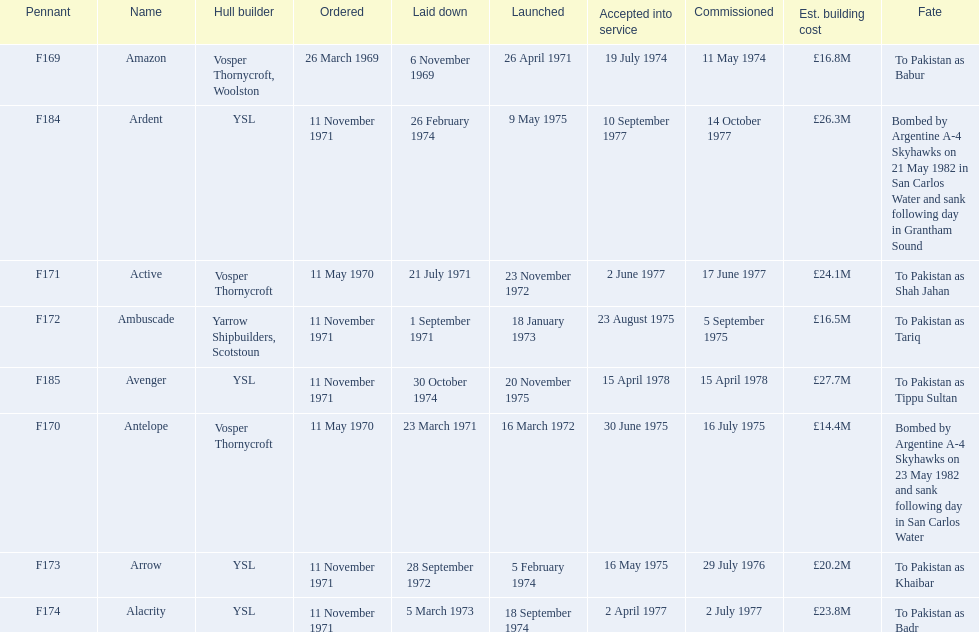What is the last listed pennant? F185. Would you mind parsing the complete table? {'header': ['Pennant', 'Name', 'Hull builder', 'Ordered', 'Laid down', 'Launched', 'Accepted into service', 'Commissioned', 'Est. building cost', 'Fate'], 'rows': [['F169', 'Amazon', 'Vosper Thornycroft, Woolston', '26 March 1969', '6 November 1969', '26 April 1971', '19 July 1974', '11 May 1974', '£16.8M', 'To Pakistan as Babur'], ['F184', 'Ardent', 'YSL', '11 November 1971', '26 February 1974', '9 May 1975', '10 September 1977', '14 October 1977', '£26.3M', 'Bombed by Argentine A-4 Skyhawks on 21 May 1982 in San Carlos Water and sank following day in Grantham Sound'], ['F171', 'Active', 'Vosper Thornycroft', '11 May 1970', '21 July 1971', '23 November 1972', '2 June 1977', '17 June 1977', '£24.1M', 'To Pakistan as Shah Jahan'], ['F172', 'Ambuscade', 'Yarrow Shipbuilders, Scotstoun', '11 November 1971', '1 September 1971', '18 January 1973', '23 August 1975', '5 September 1975', '£16.5M', 'To Pakistan as Tariq'], ['F185', 'Avenger', 'YSL', '11 November 1971', '30 October 1974', '20 November 1975', '15 April 1978', '15 April 1978', '£27.7M', 'To Pakistan as Tippu Sultan'], ['F170', 'Antelope', 'Vosper Thornycroft', '11 May 1970', '23 March 1971', '16 March 1972', '30 June 1975', '16 July 1975', '£14.4M', 'Bombed by Argentine A-4 Skyhawks on 23 May 1982 and sank following day in San Carlos Water'], ['F173', 'Arrow', 'YSL', '11 November 1971', '28 September 1972', '5 February 1974', '16 May 1975', '29 July 1976', '£20.2M', 'To Pakistan as Khaibar'], ['F174', 'Alacrity', 'YSL', '11 November 1971', '5 March 1973', '18 September 1974', '2 April 1977', '2 July 1977', '£23.8M', 'To Pakistan as Badr']]} 